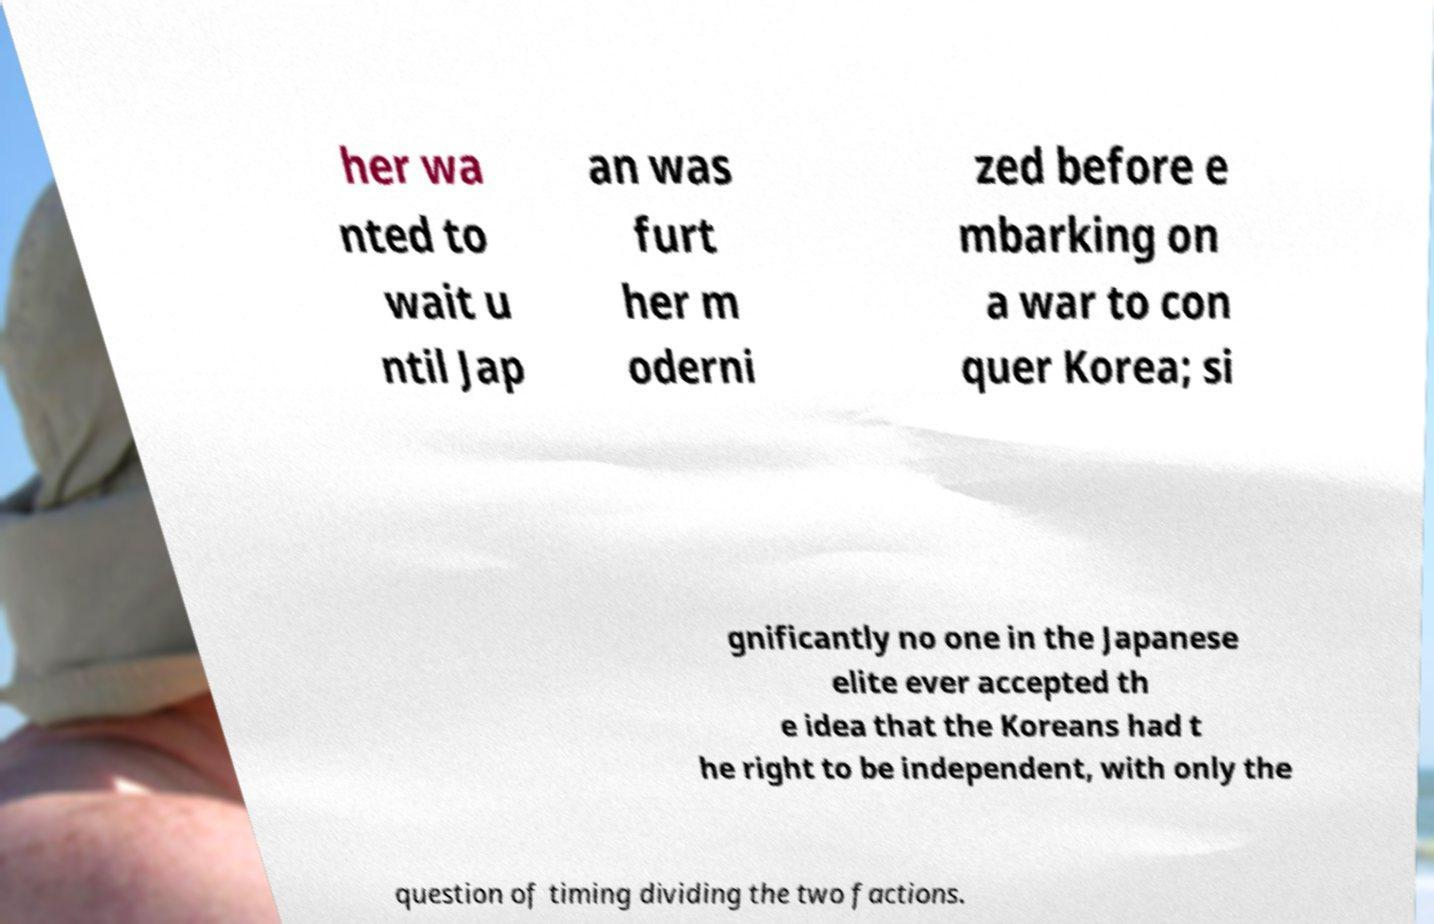For documentation purposes, I need the text within this image transcribed. Could you provide that? her wa nted to wait u ntil Jap an was furt her m oderni zed before e mbarking on a war to con quer Korea; si gnificantly no one in the Japanese elite ever accepted th e idea that the Koreans had t he right to be independent, with only the question of timing dividing the two factions. 